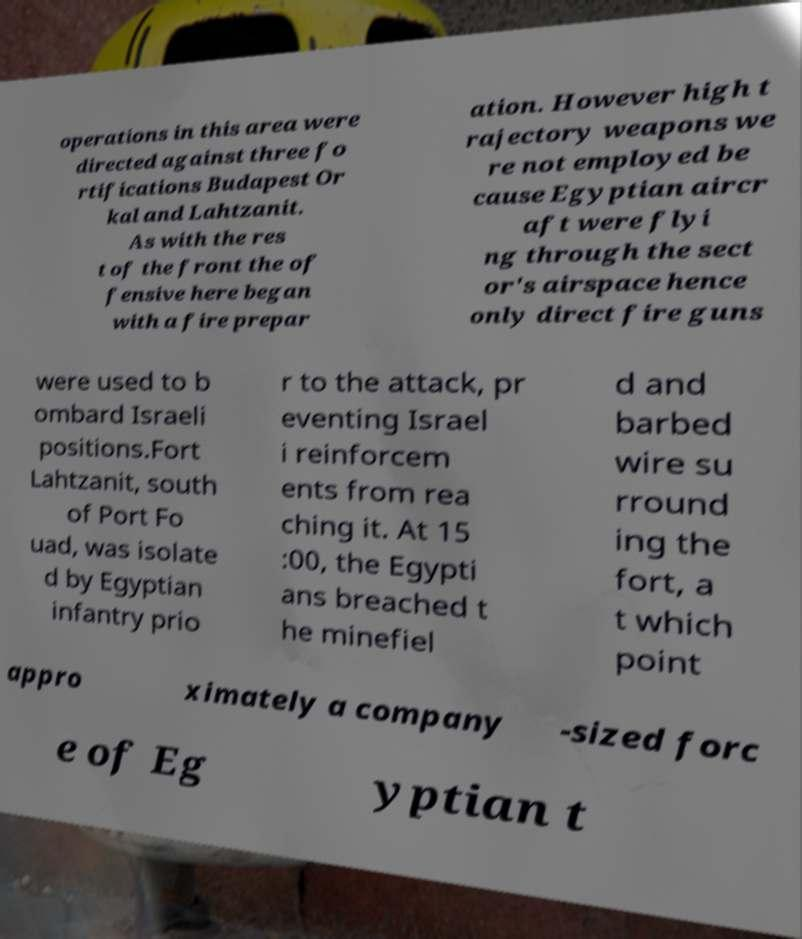What messages or text are displayed in this image? I need them in a readable, typed format. operations in this area were directed against three fo rtifications Budapest Or kal and Lahtzanit. As with the res t of the front the of fensive here began with a fire prepar ation. However high t rajectory weapons we re not employed be cause Egyptian aircr aft were flyi ng through the sect or's airspace hence only direct fire guns were used to b ombard Israeli positions.Fort Lahtzanit, south of Port Fo uad, was isolate d by Egyptian infantry prio r to the attack, pr eventing Israel i reinforcem ents from rea ching it. At 15 :00, the Egypti ans breached t he minefiel d and barbed wire su rround ing the fort, a t which point appro ximately a company -sized forc e of Eg yptian t 